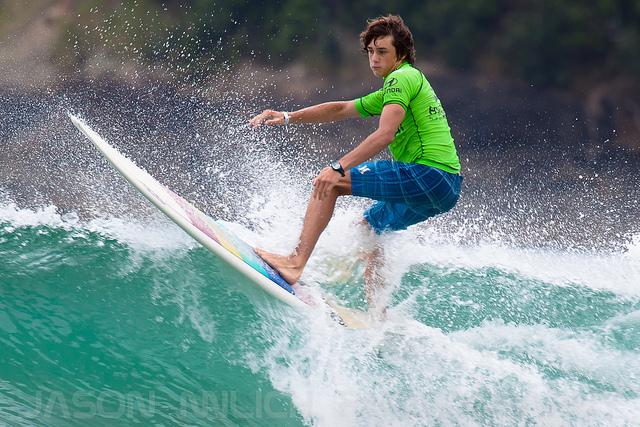Is the surfer concentrating?
Concise answer only. Yes. Is the surfboard in the water?
Be succinct. Yes. Is the surfer wearing a watch?
Quick response, please. Yes. 